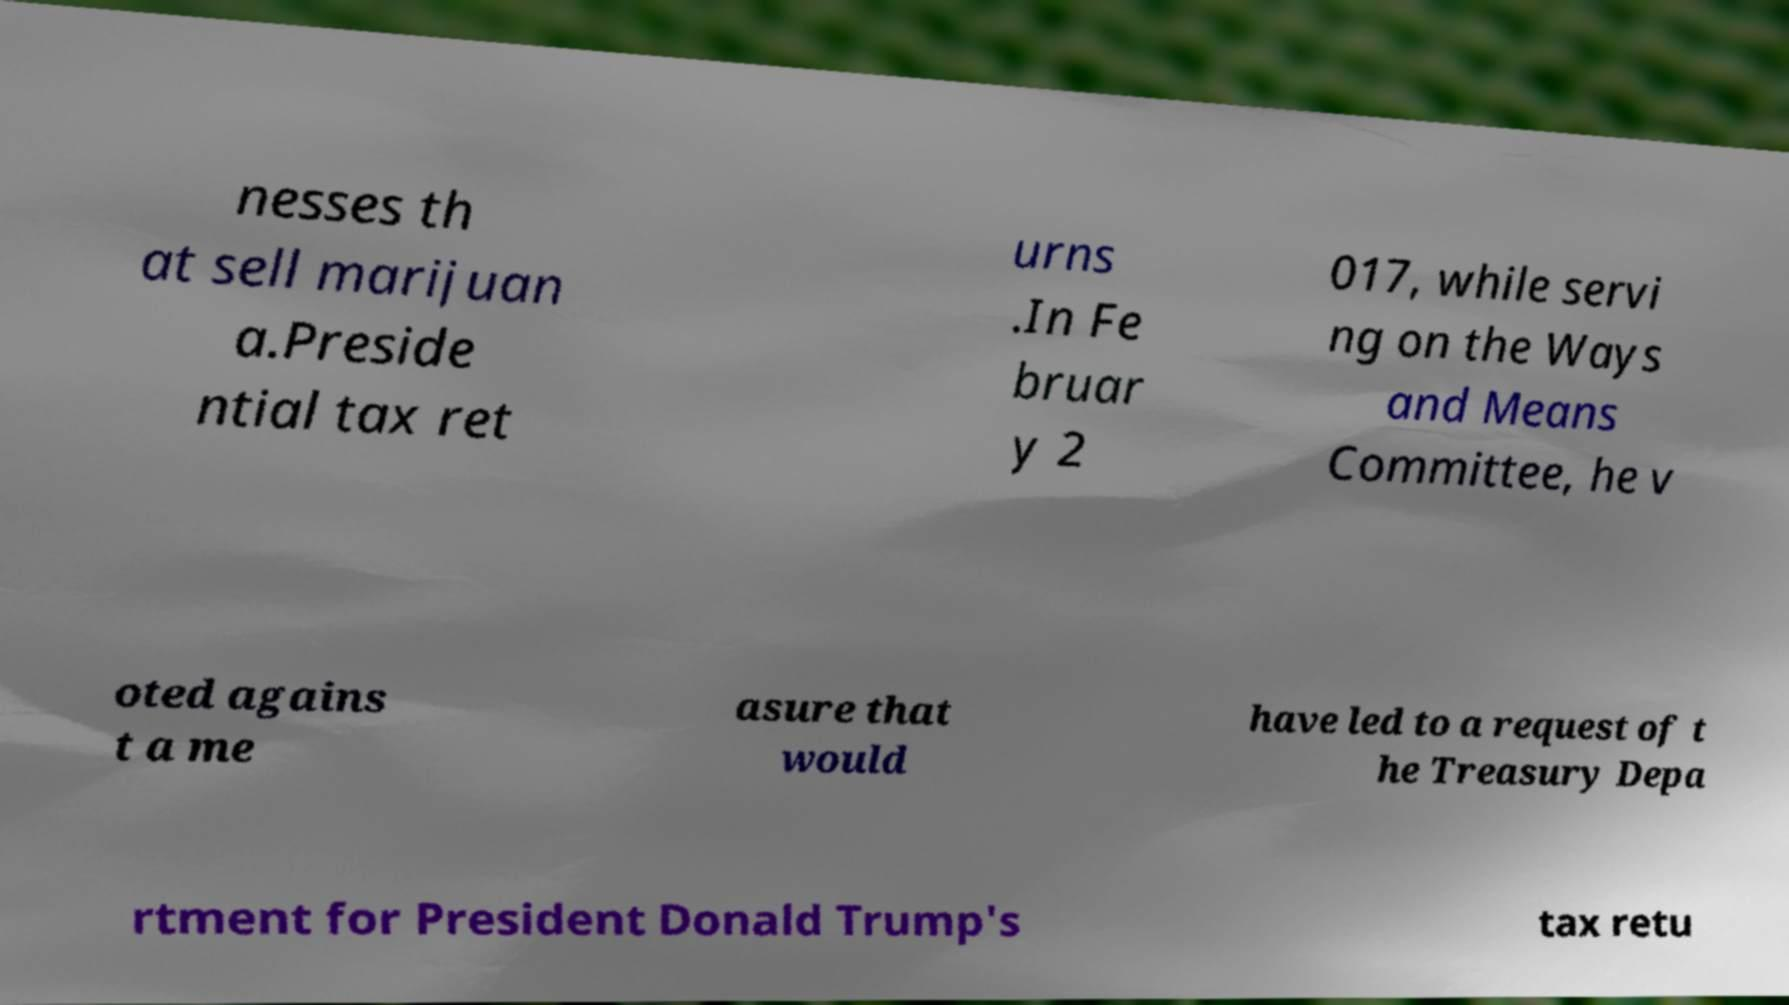Can you read and provide the text displayed in the image?This photo seems to have some interesting text. Can you extract and type it out for me? nesses th at sell marijuan a.Preside ntial tax ret urns .In Fe bruar y 2 017, while servi ng on the Ways and Means Committee, he v oted agains t a me asure that would have led to a request of t he Treasury Depa rtment for President Donald Trump's tax retu 